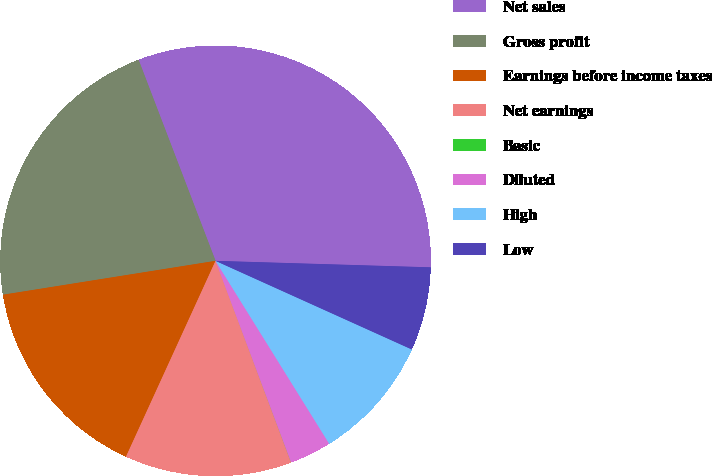Convert chart. <chart><loc_0><loc_0><loc_500><loc_500><pie_chart><fcel>Net sales<fcel>Gross profit<fcel>Earnings before income taxes<fcel>Net earnings<fcel>Basic<fcel>Diluted<fcel>High<fcel>Low<nl><fcel>31.3%<fcel>21.7%<fcel>15.66%<fcel>12.53%<fcel>0.01%<fcel>3.14%<fcel>9.4%<fcel>6.27%<nl></chart> 